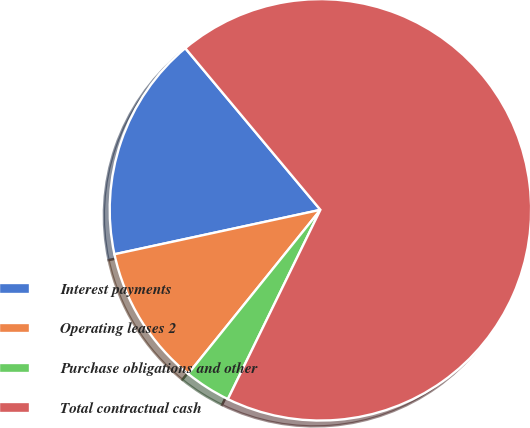Convert chart to OTSL. <chart><loc_0><loc_0><loc_500><loc_500><pie_chart><fcel>Interest payments<fcel>Operating leases 2<fcel>Purchase obligations and other<fcel>Total contractual cash<nl><fcel>17.3%<fcel>10.82%<fcel>3.56%<fcel>68.32%<nl></chart> 